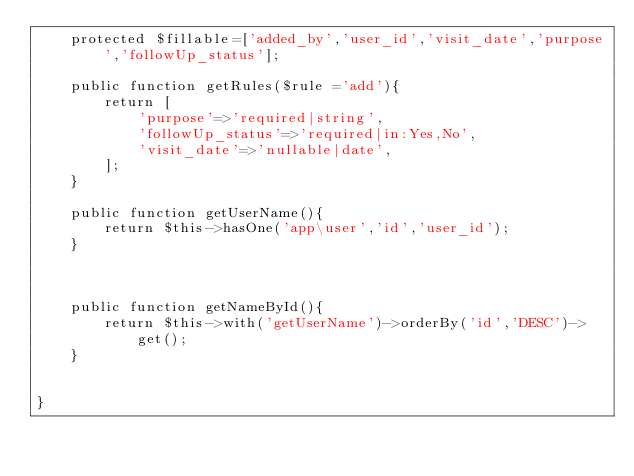<code> <loc_0><loc_0><loc_500><loc_500><_PHP_>    protected $fillable=['added_by','user_id','visit_date','purpose','followUp_status'];

    public function getRules($rule ='add'){
        return [
            'purpose'=>'required|string',
            'followUp_status'=>'required|in:Yes,No',
            'visit_date'=>'nullable|date',
        ];
    }

    public function getUserName(){
        return $this->hasOne('app\user','id','user_id');
    }

   

    public function getNameById(){
        return $this->with('getUserName')->orderBy('id','DESC')->get();
    }

   
}
</code> 